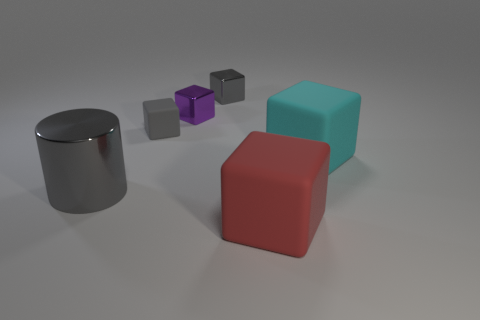What is the shape of the small shiny object that is the same color as the big cylinder?
Your response must be concise. Cube. Are there any large gray cylinders?
Offer a terse response. Yes. There is a tiny purple thing that is the same material as the big gray cylinder; what is its shape?
Ensure brevity in your answer.  Cube. There is a large object behind the large shiny cylinder; what is its material?
Offer a very short reply. Rubber. Do the tiny metallic cube left of the tiny gray metallic object and the large shiny object have the same color?
Make the answer very short. No. There is a metal object in front of the matte block that is on the left side of the large red block; what is its size?
Provide a short and direct response. Large. Are there more big objects that are in front of the metallic cylinder than large red rubber things?
Provide a succinct answer. No. There is a rubber cube that is on the left side of the red thing; is its size the same as the big cylinder?
Give a very brief answer. No. The thing that is both to the left of the large red cube and in front of the cyan matte cube is what color?
Offer a terse response. Gray. What shape is the gray metal object that is the same size as the gray rubber object?
Provide a short and direct response. Cube. 